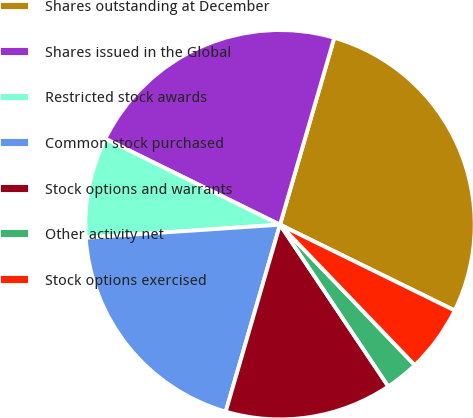Convert chart to OTSL. <chart><loc_0><loc_0><loc_500><loc_500><pie_chart><fcel>Shares outstanding at December<fcel>Shares issued in the Global<fcel>Restricted stock awards<fcel>Common stock purchased<fcel>Stock options and warrants<fcel>Other activity net<fcel>Stock options exercised<nl><fcel>27.77%<fcel>22.22%<fcel>8.34%<fcel>19.44%<fcel>13.89%<fcel>2.78%<fcel>5.56%<nl></chart> 